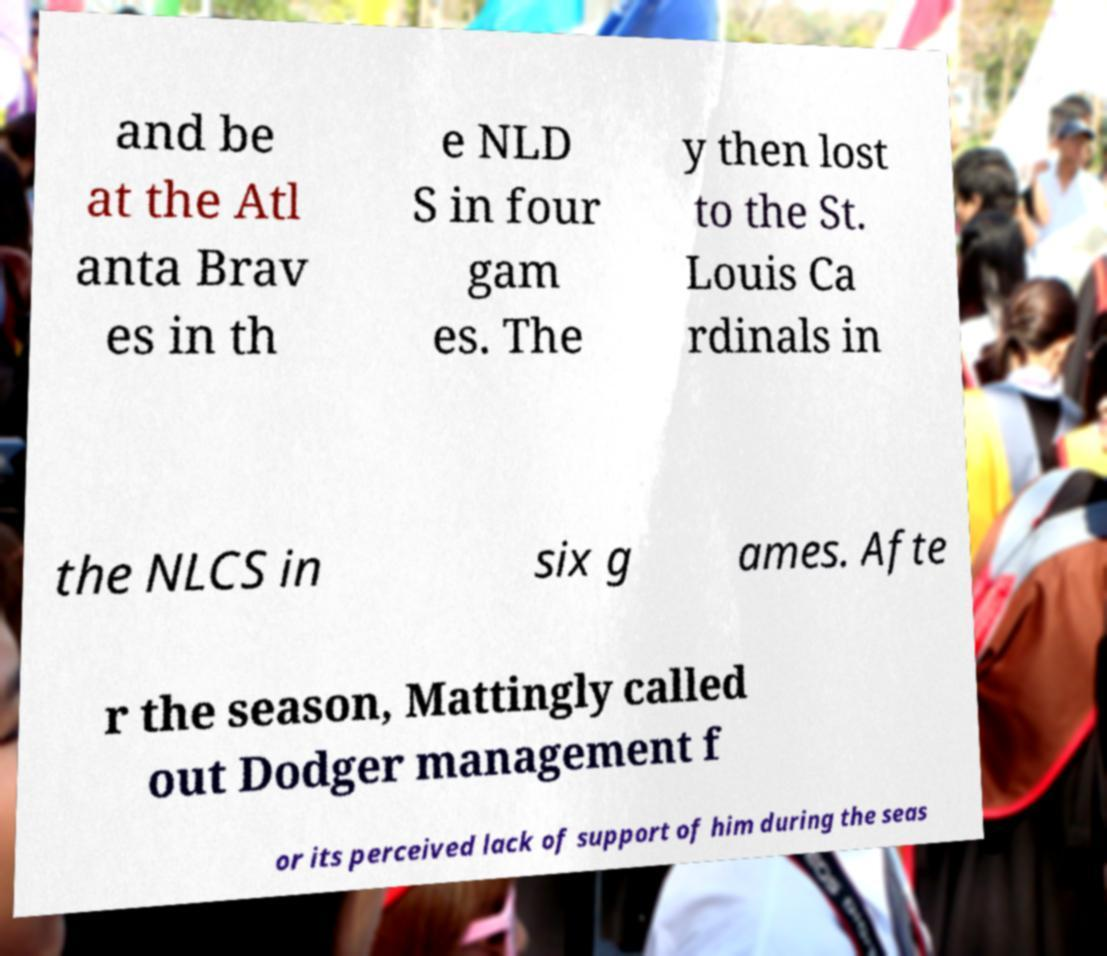Can you accurately transcribe the text from the provided image for me? and be at the Atl anta Brav es in th e NLD S in four gam es. The y then lost to the St. Louis Ca rdinals in the NLCS in six g ames. Afte r the season, Mattingly called out Dodger management f or its perceived lack of support of him during the seas 